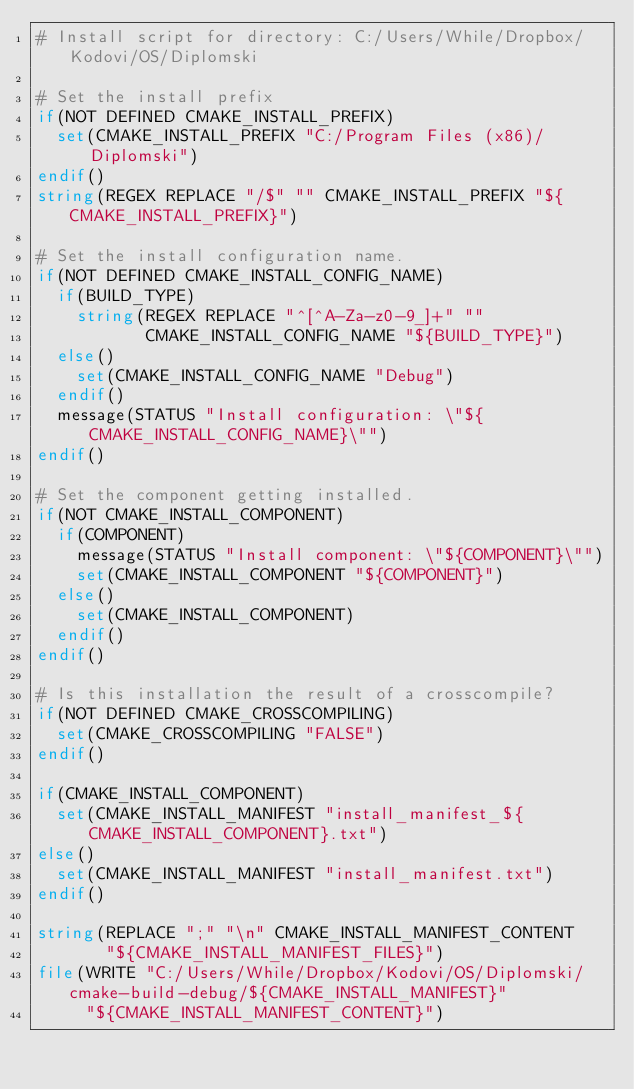<code> <loc_0><loc_0><loc_500><loc_500><_CMake_># Install script for directory: C:/Users/While/Dropbox/Kodovi/OS/Diplomski

# Set the install prefix
if(NOT DEFINED CMAKE_INSTALL_PREFIX)
  set(CMAKE_INSTALL_PREFIX "C:/Program Files (x86)/Diplomski")
endif()
string(REGEX REPLACE "/$" "" CMAKE_INSTALL_PREFIX "${CMAKE_INSTALL_PREFIX}")

# Set the install configuration name.
if(NOT DEFINED CMAKE_INSTALL_CONFIG_NAME)
  if(BUILD_TYPE)
    string(REGEX REPLACE "^[^A-Za-z0-9_]+" ""
           CMAKE_INSTALL_CONFIG_NAME "${BUILD_TYPE}")
  else()
    set(CMAKE_INSTALL_CONFIG_NAME "Debug")
  endif()
  message(STATUS "Install configuration: \"${CMAKE_INSTALL_CONFIG_NAME}\"")
endif()

# Set the component getting installed.
if(NOT CMAKE_INSTALL_COMPONENT)
  if(COMPONENT)
    message(STATUS "Install component: \"${COMPONENT}\"")
    set(CMAKE_INSTALL_COMPONENT "${COMPONENT}")
  else()
    set(CMAKE_INSTALL_COMPONENT)
  endif()
endif()

# Is this installation the result of a crosscompile?
if(NOT DEFINED CMAKE_CROSSCOMPILING)
  set(CMAKE_CROSSCOMPILING "FALSE")
endif()

if(CMAKE_INSTALL_COMPONENT)
  set(CMAKE_INSTALL_MANIFEST "install_manifest_${CMAKE_INSTALL_COMPONENT}.txt")
else()
  set(CMAKE_INSTALL_MANIFEST "install_manifest.txt")
endif()

string(REPLACE ";" "\n" CMAKE_INSTALL_MANIFEST_CONTENT
       "${CMAKE_INSTALL_MANIFEST_FILES}")
file(WRITE "C:/Users/While/Dropbox/Kodovi/OS/Diplomski/cmake-build-debug/${CMAKE_INSTALL_MANIFEST}"
     "${CMAKE_INSTALL_MANIFEST_CONTENT}")
</code> 